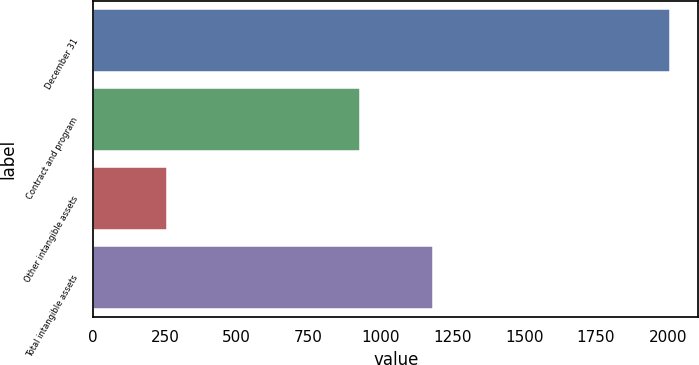<chart> <loc_0><loc_0><loc_500><loc_500><bar_chart><fcel>December 31<fcel>Contract and program<fcel>Other intangible assets<fcel>Total intangible assets<nl><fcel>2006<fcel>928<fcel>256<fcel>1184<nl></chart> 